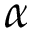<formula> <loc_0><loc_0><loc_500><loc_500>\alpha</formula> 